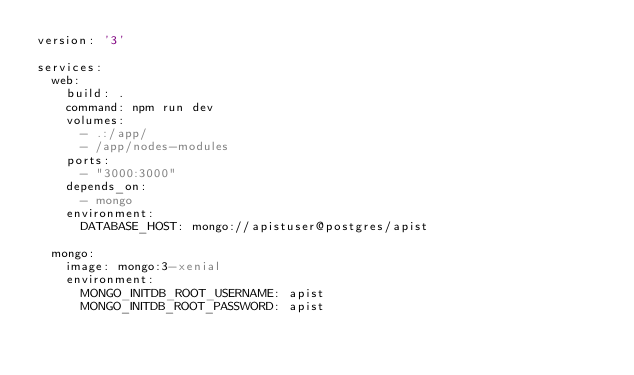<code> <loc_0><loc_0><loc_500><loc_500><_YAML_>version: '3'

services:
  web:
    build: .
    command: npm run dev
    volumes:
      - .:/app/
      - /app/nodes-modules
    ports:
      - "3000:3000"
    depends_on:
      - mongo
    environment:
      DATABASE_HOST: mongo://apistuser@postgres/apist
  
  mongo:
    image: mongo:3-xenial
    environment:
      MONGO_INITDB_ROOT_USERNAME: apist
      MONGO_INITDB_ROOT_PASSWORD: apist</code> 